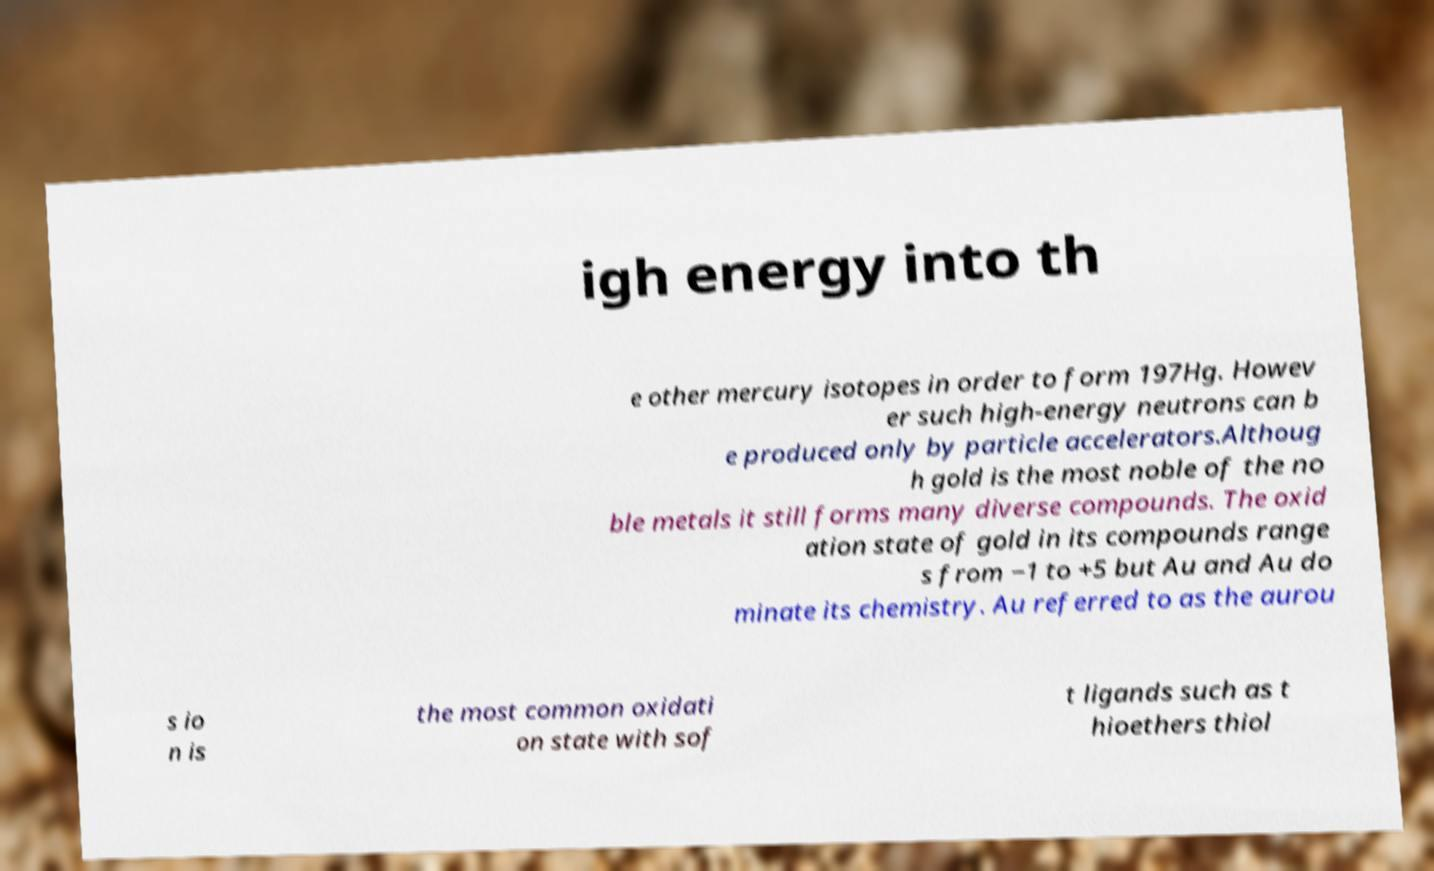What messages or text are displayed in this image? I need them in a readable, typed format. igh energy into th e other mercury isotopes in order to form 197Hg. Howev er such high-energy neutrons can b e produced only by particle accelerators.Althoug h gold is the most noble of the no ble metals it still forms many diverse compounds. The oxid ation state of gold in its compounds range s from −1 to +5 but Au and Au do minate its chemistry. Au referred to as the aurou s io n is the most common oxidati on state with sof t ligands such as t hioethers thiol 